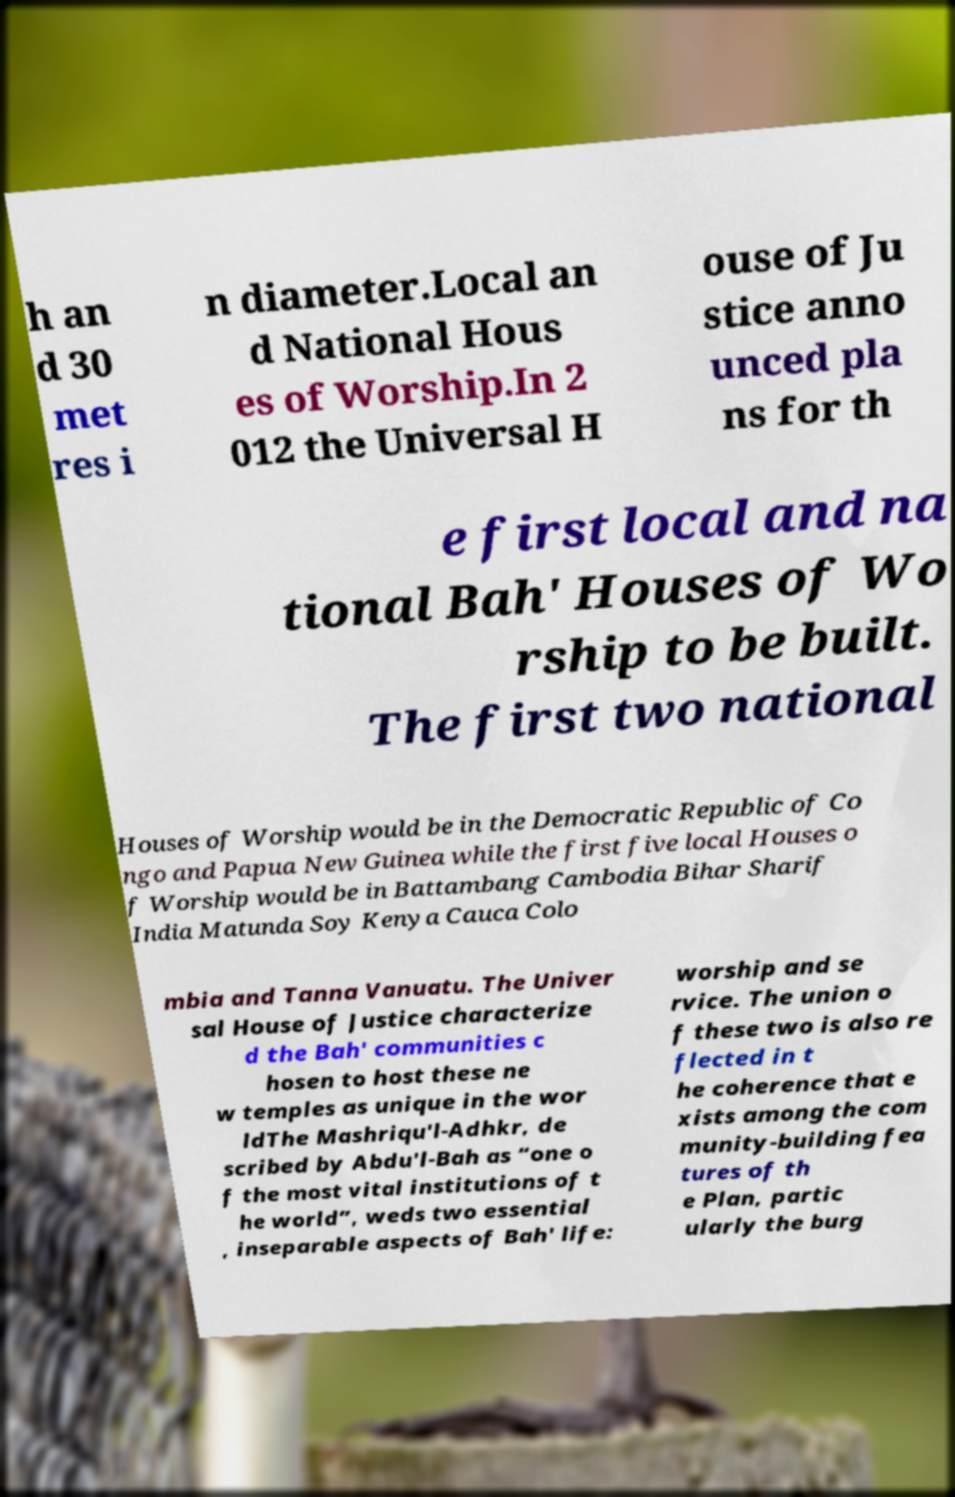For documentation purposes, I need the text within this image transcribed. Could you provide that? h an d 30 met res i n diameter.Local an d National Hous es of Worship.In 2 012 the Universal H ouse of Ju stice anno unced pla ns for th e first local and na tional Bah' Houses of Wo rship to be built. The first two national Houses of Worship would be in the Democratic Republic of Co ngo and Papua New Guinea while the first five local Houses o f Worship would be in Battambang Cambodia Bihar Sharif India Matunda Soy Kenya Cauca Colo mbia and Tanna Vanuatu. The Univer sal House of Justice characterize d the Bah' communities c hosen to host these ne w temples as unique in the wor ldThe Mashriqu'l-Adhkr, de scribed by Abdu'l-Bah as “one o f the most vital institutions of t he world”, weds two essential , inseparable aspects of Bah' life: worship and se rvice. The union o f these two is also re flected in t he coherence that e xists among the com munity-building fea tures of th e Plan, partic ularly the burg 